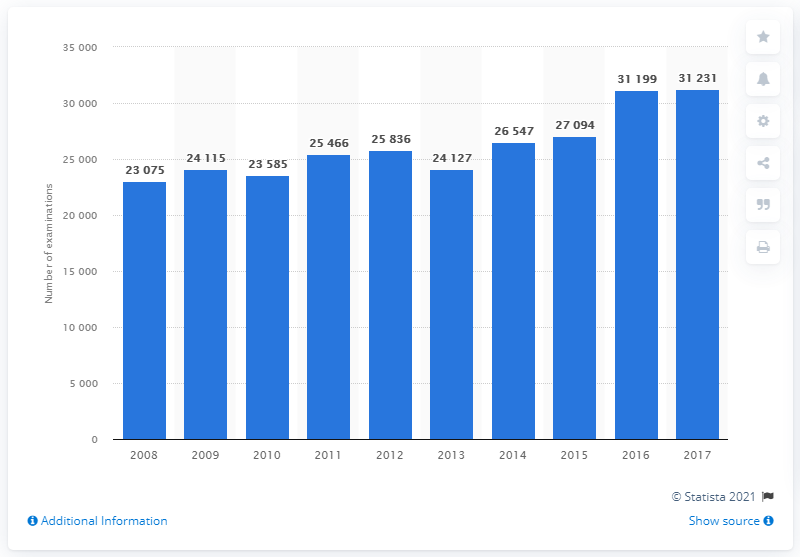List a handful of essential elements in this visual. In 2017, a total of 31,231 MRI scan examinations were conducted in Iceland. 